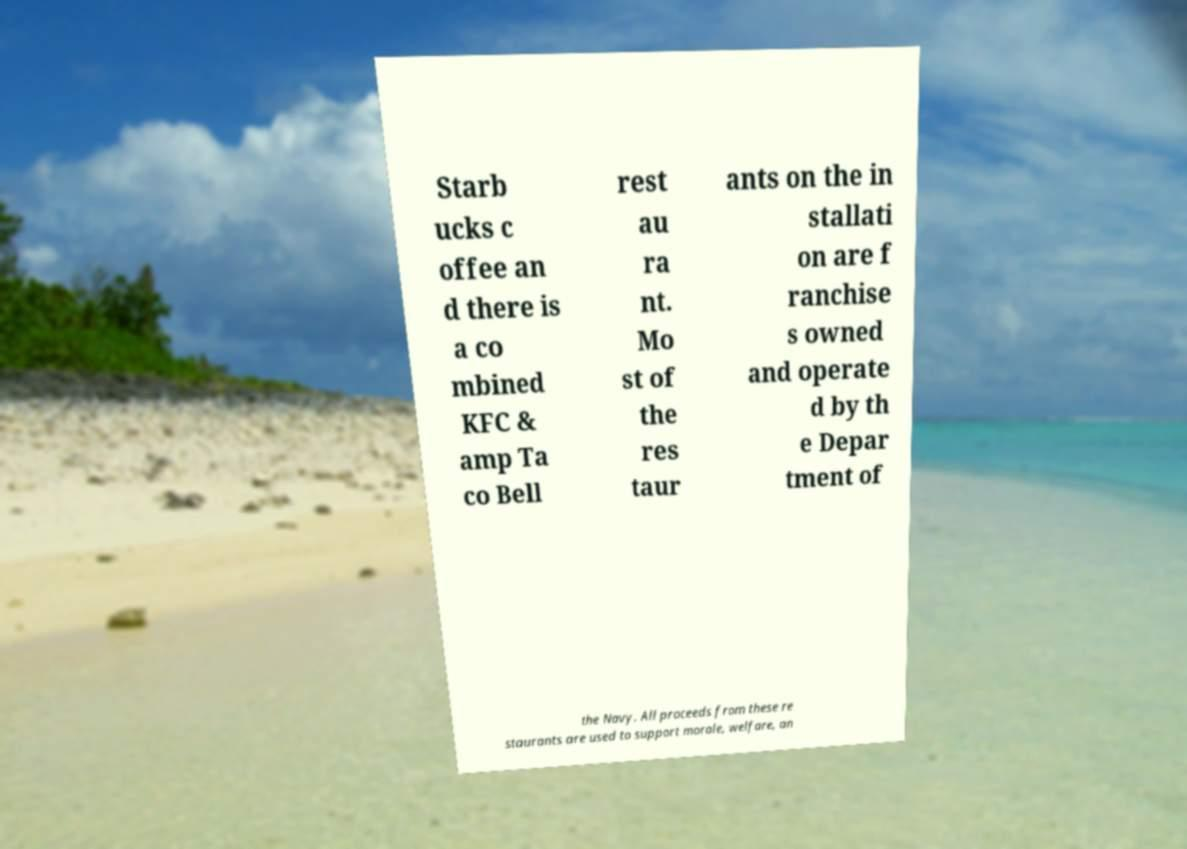Please read and relay the text visible in this image. What does it say? Starb ucks c offee an d there is a co mbined KFC & amp Ta co Bell rest au ra nt. Mo st of the res taur ants on the in stallati on are f ranchise s owned and operate d by th e Depar tment of the Navy. All proceeds from these re staurants are used to support morale, welfare, an 